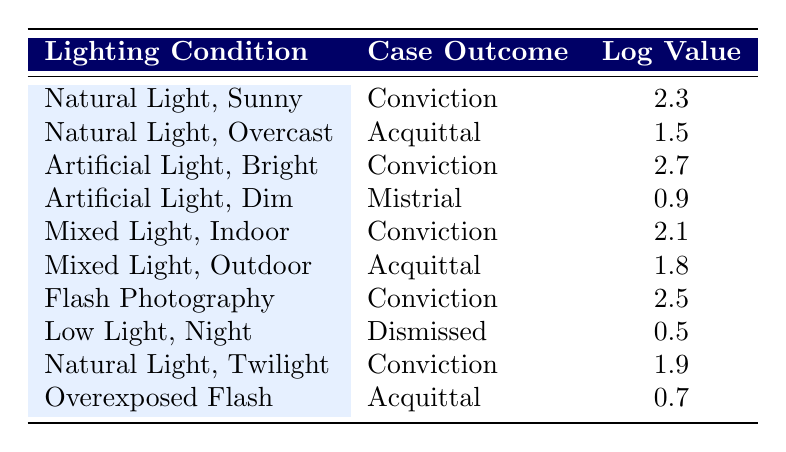What's the case outcome for "Artificial Light, Bright"? The table indicates the case outcome listed under the "Artificial Light, Bright" lighting condition is "Conviction."
Answer: Conviction What is the log value for "Low Light, Night"? The table shows that the log value corresponding to "Low Light, Night" is 0.5.
Answer: 0.5 How many case outcomes resulted in a conviction? By counting the rows with "Conviction" listed in the case outcome column, we find there are 5 cases: "Natural Light, Sunny," "Artificial Light, Bright," "Mixed Light, Indoor," "Flash Photography," and "Natural Light, Twilight."
Answer: 5 Is there any lighting condition where the outcome is "Dismissed"? The table lists "Low Light, Night" as the only lighting condition resulting in "Dismissed." Therefore, the answer is yes.
Answer: Yes What is the average log value for all case outcomes with a conviction? The log values for convictions are 2.3, 2.7, 2.1, 2.5, and 1.9. Summing these values: 2.3 + 2.7 + 2.1 + 2.5 + 1.9 = 11.5. There are 5 conviction cases, so the average is 11.5 / 5 = 2.3.
Answer: 2.3 Which lighting condition has the highest log value and what is the case outcome? By examining the log values in the table, "Artificial Light, Bright" has the highest log value of 2.7, and the case outcome for this condition is "Conviction."
Answer: Artificial Light, Bright; Conviction What is the difference in log values between "Natural Light, Overcast" and "Overexposed Flash"? The log value for "Natural Light, Overcast" is 1.5 and for "Overexposed Flash," it is 0.7. The difference is calculated as 1.5 - 0.7 = 0.8.
Answer: 0.8 How many cases with "Acquittal" have a log value greater than 1? The cases with "Acquittal" are "Natural Light, Overcast" (1.5) and "Mixed Light, Outdoor" (1.8). Thus, there are 2 cases with a log value greater than 1.
Answer: 2 Are there any lighting conditions resulting in a mistrial? According to the table, "Artificial Light, Dim" is the lighting condition that results in a mistrial.
Answer: Yes 